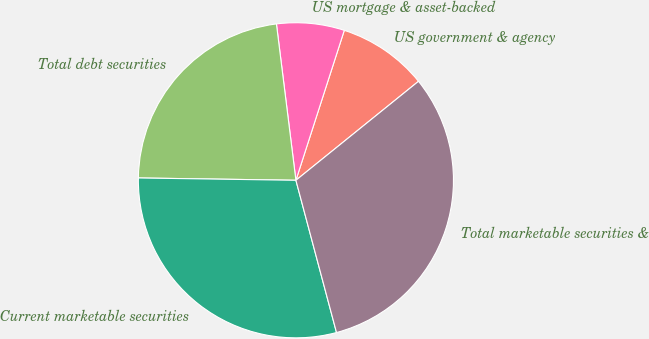Convert chart to OTSL. <chart><loc_0><loc_0><loc_500><loc_500><pie_chart><fcel>US government & agency<fcel>US mortgage & asset-backed<fcel>Total debt securities<fcel>Current marketable securities<fcel>Total marketable securities &<nl><fcel>9.22%<fcel>6.94%<fcel>22.79%<fcel>29.38%<fcel>31.66%<nl></chart> 